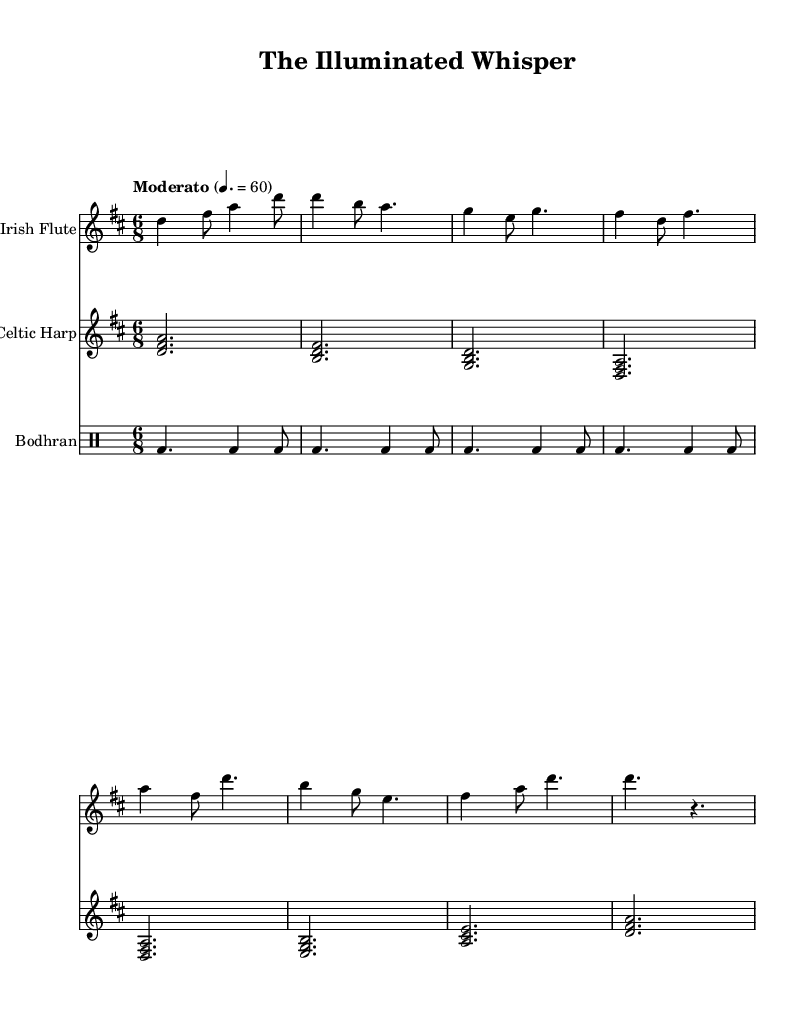What is the key signature of this music? The key signature is D major, which has two sharps (F# and C#). This can be identified by looking at the key signature indicated at the beginning of the sheet music.
Answer: D major What is the time signature of this piece? The time signature shown at the beginning of the score is 6/8, which indicates there are six beats in each measure and the eighth note gets one beat. This is clearly marked on the sheet music.
Answer: 6/8 What is the indicated tempo for this piece? The tempo marking is "Moderato" with a specific metronomic indication of 60 beats per minute. This information is usually placed at the beginning of the score, guiding the musician on the speed of the performance.
Answer: 60 How many measures are in the flute part? The flute part consists of 8 measures, which can be counted by looking at the bar lines that separate each measure on the staff.
Answer: 8 What instruments are featured in this score? The score features three instruments: Irish Flute, Celtic Harp, and Bodhran. The instruments are labeled at the beginning of each staff within the score.
Answer: Irish Flute, Celtic Harp, Bodhran What rhythmic pattern is used for the Bodhran? The rhythmic pattern for the Bodhran includes a combination of quarter notes and eighth notes, specifically a consistent pattern represented as dotted quarter notes followed by eighth notes throughout the score. This can be discerned by examining the drum notation provided.
Answer: Quarter and eighth notes 